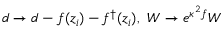Convert formula to latex. <formula><loc_0><loc_0><loc_500><loc_500>d \rightarrow d - f ( z _ { i } ) - f ^ { \dagger } ( z _ { i } ) , W \rightarrow e ^ { \kappa ^ { 2 } f } W</formula> 